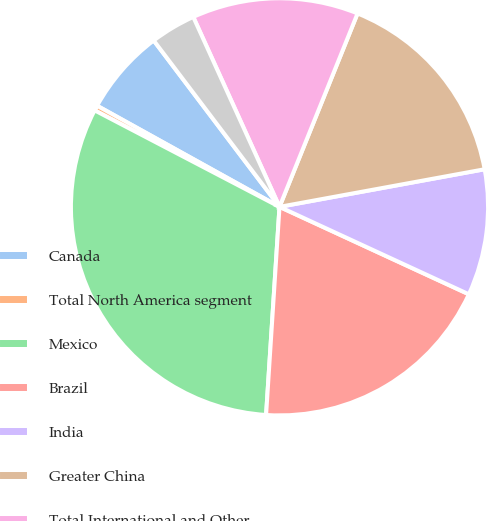<chart> <loc_0><loc_0><loc_500><loc_500><pie_chart><fcel>Canada<fcel>Total North America segment<fcel>Mexico<fcel>Brazil<fcel>India<fcel>Greater China<fcel>Total International and Other<fcel>Total Company<nl><fcel>6.64%<fcel>0.4%<fcel>31.63%<fcel>19.14%<fcel>9.77%<fcel>16.01%<fcel>12.89%<fcel>3.52%<nl></chart> 